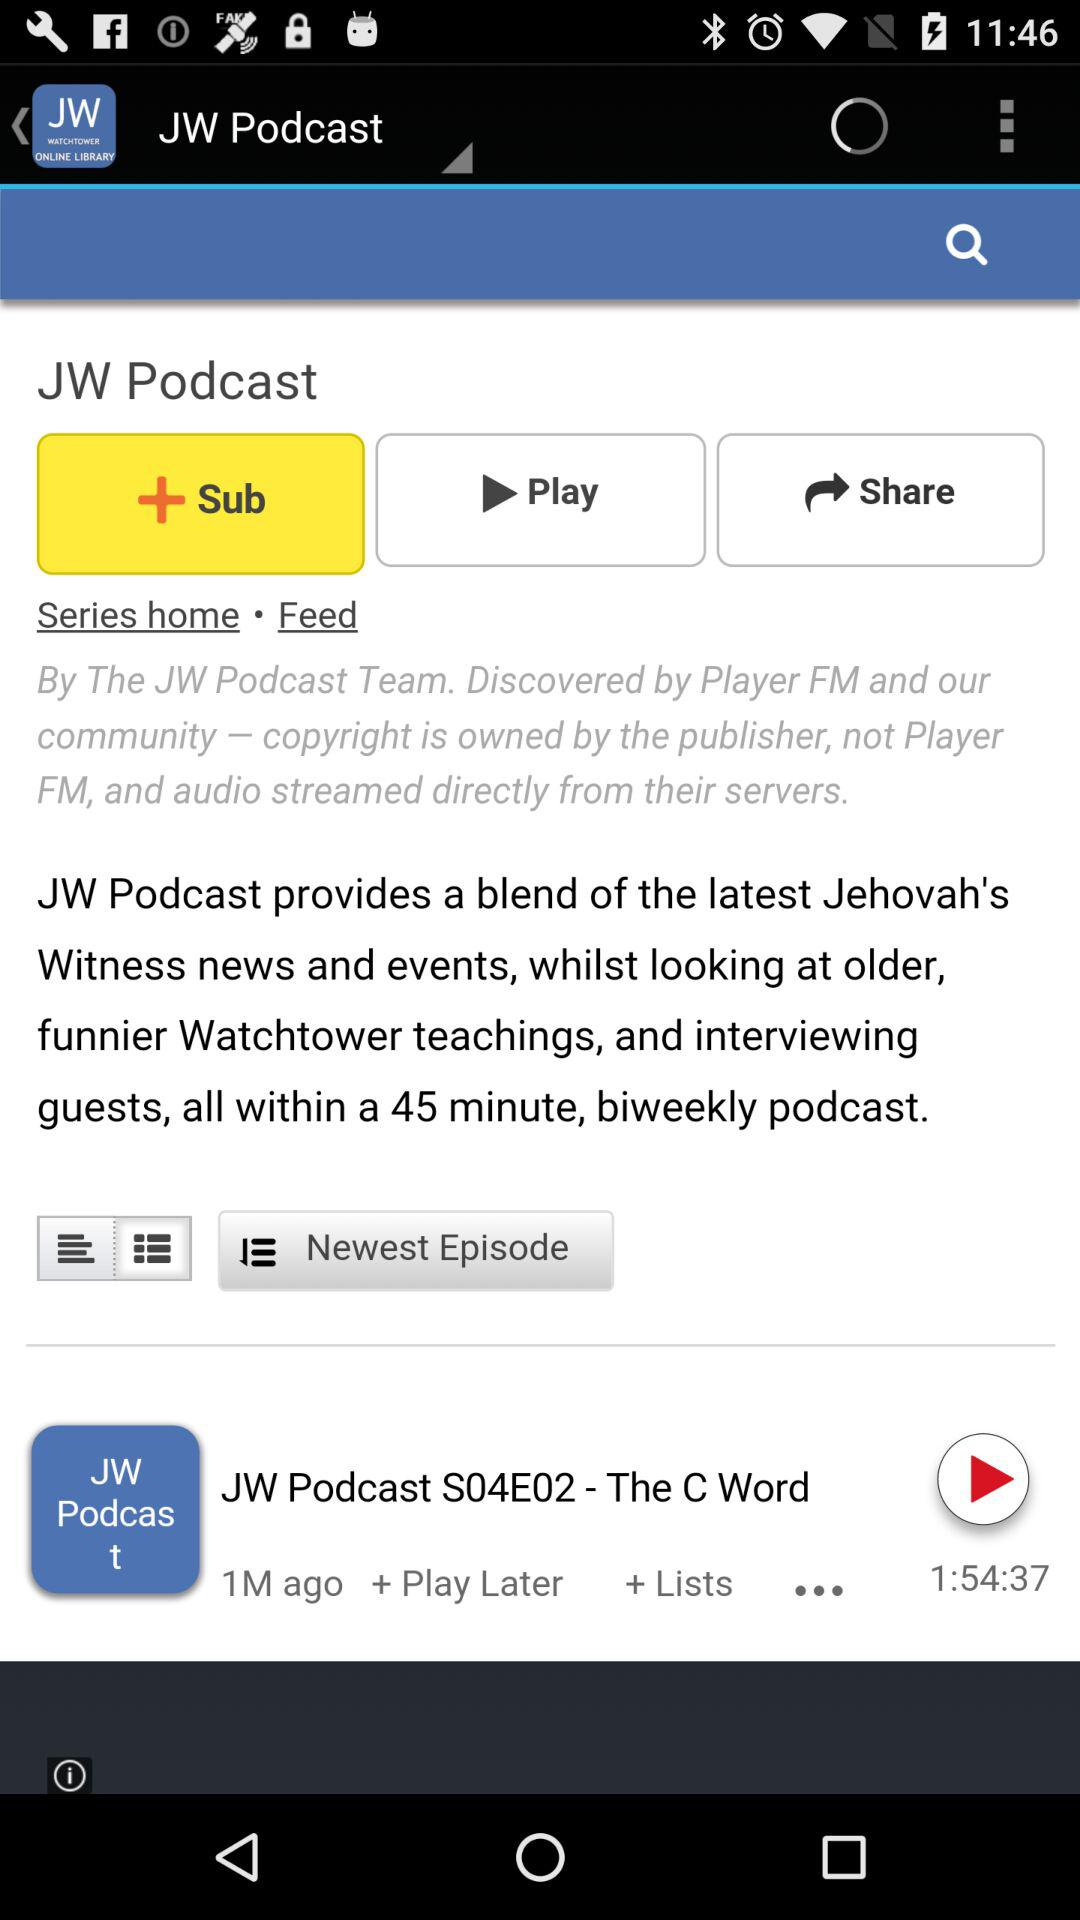What is the name of the podcast? The name of the podcast is "JW Podcast S04E02 - The C Word". 